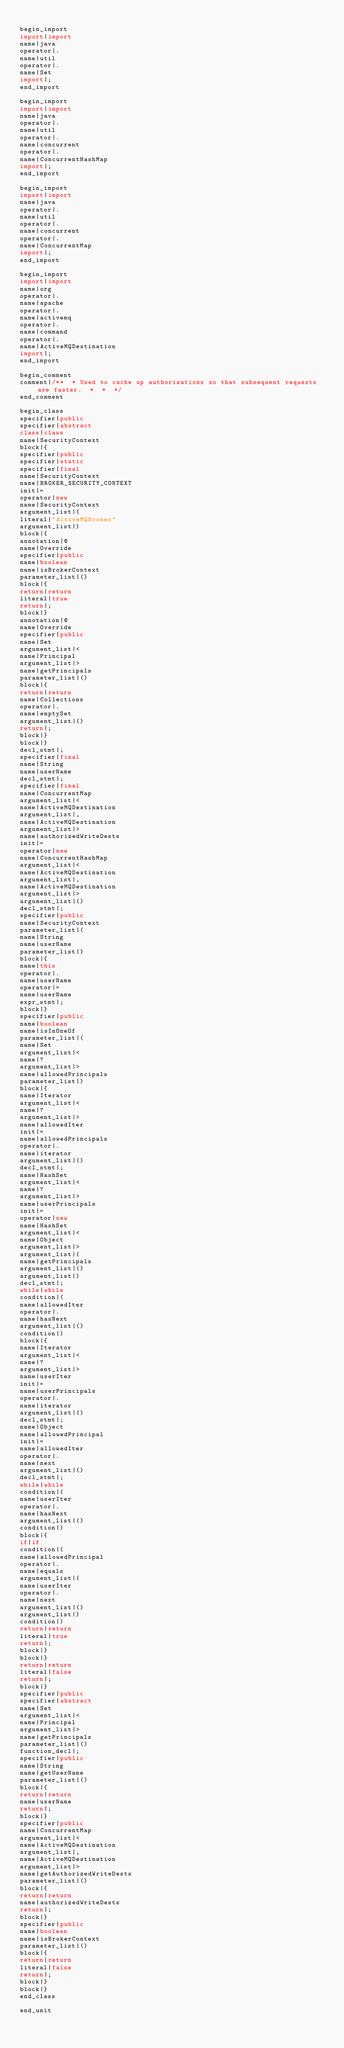<code> <loc_0><loc_0><loc_500><loc_500><_Java_>
begin_import
import|import
name|java
operator|.
name|util
operator|.
name|Set
import|;
end_import

begin_import
import|import
name|java
operator|.
name|util
operator|.
name|concurrent
operator|.
name|ConcurrentHashMap
import|;
end_import

begin_import
import|import
name|java
operator|.
name|util
operator|.
name|concurrent
operator|.
name|ConcurrentMap
import|;
end_import

begin_import
import|import
name|org
operator|.
name|apache
operator|.
name|activemq
operator|.
name|command
operator|.
name|ActiveMQDestination
import|;
end_import

begin_comment
comment|/**  * Used to cache up authorizations so that subsequent requests are faster.  *  *  */
end_comment

begin_class
specifier|public
specifier|abstract
class|class
name|SecurityContext
block|{
specifier|public
specifier|static
specifier|final
name|SecurityContext
name|BROKER_SECURITY_CONTEXT
init|=
operator|new
name|SecurityContext
argument_list|(
literal|"ActiveMQBroker"
argument_list|)
block|{
annotation|@
name|Override
specifier|public
name|boolean
name|isBrokerContext
parameter_list|()
block|{
return|return
literal|true
return|;
block|}
annotation|@
name|Override
specifier|public
name|Set
argument_list|<
name|Principal
argument_list|>
name|getPrincipals
parameter_list|()
block|{
return|return
name|Collections
operator|.
name|emptySet
argument_list|()
return|;
block|}
block|}
decl_stmt|;
specifier|final
name|String
name|userName
decl_stmt|;
specifier|final
name|ConcurrentMap
argument_list|<
name|ActiveMQDestination
argument_list|,
name|ActiveMQDestination
argument_list|>
name|authorizedWriteDests
init|=
operator|new
name|ConcurrentHashMap
argument_list|<
name|ActiveMQDestination
argument_list|,
name|ActiveMQDestination
argument_list|>
argument_list|()
decl_stmt|;
specifier|public
name|SecurityContext
parameter_list|(
name|String
name|userName
parameter_list|)
block|{
name|this
operator|.
name|userName
operator|=
name|userName
expr_stmt|;
block|}
specifier|public
name|boolean
name|isInOneOf
parameter_list|(
name|Set
argument_list|<
name|?
argument_list|>
name|allowedPrincipals
parameter_list|)
block|{
name|Iterator
argument_list|<
name|?
argument_list|>
name|allowedIter
init|=
name|allowedPrincipals
operator|.
name|iterator
argument_list|()
decl_stmt|;
name|HashSet
argument_list|<
name|?
argument_list|>
name|userPrincipals
init|=
operator|new
name|HashSet
argument_list|<
name|Object
argument_list|>
argument_list|(
name|getPrincipals
argument_list|()
argument_list|)
decl_stmt|;
while|while
condition|(
name|allowedIter
operator|.
name|hasNext
argument_list|()
condition|)
block|{
name|Iterator
argument_list|<
name|?
argument_list|>
name|userIter
init|=
name|userPrincipals
operator|.
name|iterator
argument_list|()
decl_stmt|;
name|Object
name|allowedPrincipal
init|=
name|allowedIter
operator|.
name|next
argument_list|()
decl_stmt|;
while|while
condition|(
name|userIter
operator|.
name|hasNext
argument_list|()
condition|)
block|{
if|if
condition|(
name|allowedPrincipal
operator|.
name|equals
argument_list|(
name|userIter
operator|.
name|next
argument_list|()
argument_list|)
condition|)
return|return
literal|true
return|;
block|}
block|}
return|return
literal|false
return|;
block|}
specifier|public
specifier|abstract
name|Set
argument_list|<
name|Principal
argument_list|>
name|getPrincipals
parameter_list|()
function_decl|;
specifier|public
name|String
name|getUserName
parameter_list|()
block|{
return|return
name|userName
return|;
block|}
specifier|public
name|ConcurrentMap
argument_list|<
name|ActiveMQDestination
argument_list|,
name|ActiveMQDestination
argument_list|>
name|getAuthorizedWriteDests
parameter_list|()
block|{
return|return
name|authorizedWriteDests
return|;
block|}
specifier|public
name|boolean
name|isBrokerContext
parameter_list|()
block|{
return|return
literal|false
return|;
block|}
block|}
end_class

end_unit

</code> 